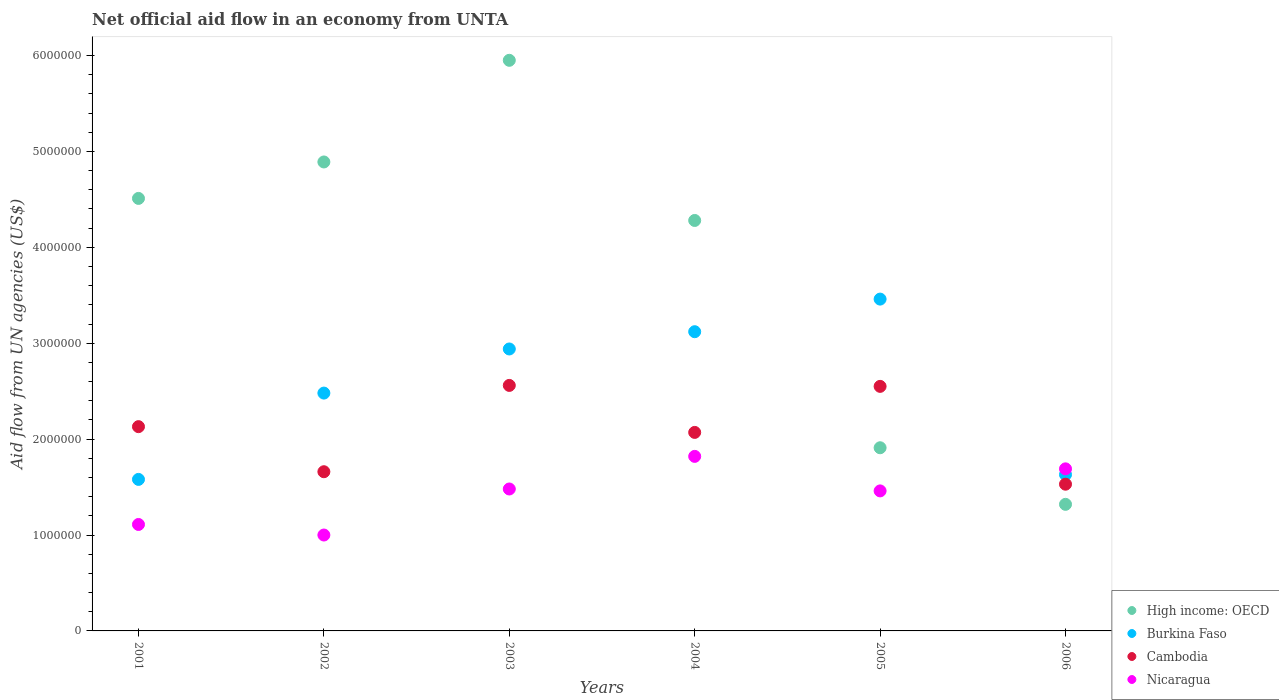Is the number of dotlines equal to the number of legend labels?
Give a very brief answer. Yes. What is the net official aid flow in High income: OECD in 2003?
Your response must be concise. 5.95e+06. Across all years, what is the maximum net official aid flow in Cambodia?
Provide a short and direct response. 2.56e+06. What is the total net official aid flow in Nicaragua in the graph?
Keep it short and to the point. 8.56e+06. What is the difference between the net official aid flow in High income: OECD in 2001 and that in 2006?
Your response must be concise. 3.19e+06. What is the difference between the net official aid flow in Cambodia in 2004 and the net official aid flow in Burkina Faso in 2005?
Your answer should be compact. -1.39e+06. What is the average net official aid flow in Burkina Faso per year?
Keep it short and to the point. 2.54e+06. In the year 2005, what is the difference between the net official aid flow in High income: OECD and net official aid flow in Burkina Faso?
Keep it short and to the point. -1.55e+06. What is the ratio of the net official aid flow in High income: OECD in 2001 to that in 2005?
Your response must be concise. 2.36. Is the difference between the net official aid flow in High income: OECD in 2001 and 2006 greater than the difference between the net official aid flow in Burkina Faso in 2001 and 2006?
Your response must be concise. Yes. What is the difference between the highest and the lowest net official aid flow in Burkina Faso?
Your answer should be compact. 1.88e+06. Is it the case that in every year, the sum of the net official aid flow in Cambodia and net official aid flow in Burkina Faso  is greater than the sum of net official aid flow in Nicaragua and net official aid flow in High income: OECD?
Provide a succinct answer. No. Is it the case that in every year, the sum of the net official aid flow in Burkina Faso and net official aid flow in High income: OECD  is greater than the net official aid flow in Nicaragua?
Give a very brief answer. Yes. Does the net official aid flow in Cambodia monotonically increase over the years?
Your response must be concise. No. Is the net official aid flow in Nicaragua strictly less than the net official aid flow in High income: OECD over the years?
Provide a succinct answer. No. How many dotlines are there?
Offer a very short reply. 4. How many years are there in the graph?
Offer a terse response. 6. Does the graph contain grids?
Your answer should be very brief. No. Where does the legend appear in the graph?
Your response must be concise. Bottom right. How many legend labels are there?
Offer a very short reply. 4. How are the legend labels stacked?
Offer a terse response. Vertical. What is the title of the graph?
Provide a short and direct response. Net official aid flow in an economy from UNTA. Does "Central African Republic" appear as one of the legend labels in the graph?
Offer a very short reply. No. What is the label or title of the Y-axis?
Offer a terse response. Aid flow from UN agencies (US$). What is the Aid flow from UN agencies (US$) in High income: OECD in 2001?
Offer a very short reply. 4.51e+06. What is the Aid flow from UN agencies (US$) in Burkina Faso in 2001?
Your response must be concise. 1.58e+06. What is the Aid flow from UN agencies (US$) of Cambodia in 2001?
Offer a terse response. 2.13e+06. What is the Aid flow from UN agencies (US$) in Nicaragua in 2001?
Provide a succinct answer. 1.11e+06. What is the Aid flow from UN agencies (US$) in High income: OECD in 2002?
Your answer should be compact. 4.89e+06. What is the Aid flow from UN agencies (US$) of Burkina Faso in 2002?
Your answer should be compact. 2.48e+06. What is the Aid flow from UN agencies (US$) in Cambodia in 2002?
Keep it short and to the point. 1.66e+06. What is the Aid flow from UN agencies (US$) of Nicaragua in 2002?
Give a very brief answer. 1.00e+06. What is the Aid flow from UN agencies (US$) of High income: OECD in 2003?
Offer a very short reply. 5.95e+06. What is the Aid flow from UN agencies (US$) of Burkina Faso in 2003?
Make the answer very short. 2.94e+06. What is the Aid flow from UN agencies (US$) in Cambodia in 2003?
Ensure brevity in your answer.  2.56e+06. What is the Aid flow from UN agencies (US$) in Nicaragua in 2003?
Your answer should be very brief. 1.48e+06. What is the Aid flow from UN agencies (US$) in High income: OECD in 2004?
Your answer should be compact. 4.28e+06. What is the Aid flow from UN agencies (US$) of Burkina Faso in 2004?
Offer a terse response. 3.12e+06. What is the Aid flow from UN agencies (US$) in Cambodia in 2004?
Your answer should be compact. 2.07e+06. What is the Aid flow from UN agencies (US$) of Nicaragua in 2004?
Give a very brief answer. 1.82e+06. What is the Aid flow from UN agencies (US$) of High income: OECD in 2005?
Your answer should be compact. 1.91e+06. What is the Aid flow from UN agencies (US$) of Burkina Faso in 2005?
Your answer should be very brief. 3.46e+06. What is the Aid flow from UN agencies (US$) of Cambodia in 2005?
Ensure brevity in your answer.  2.55e+06. What is the Aid flow from UN agencies (US$) in Nicaragua in 2005?
Make the answer very short. 1.46e+06. What is the Aid flow from UN agencies (US$) of High income: OECD in 2006?
Provide a short and direct response. 1.32e+06. What is the Aid flow from UN agencies (US$) in Burkina Faso in 2006?
Offer a very short reply. 1.63e+06. What is the Aid flow from UN agencies (US$) of Cambodia in 2006?
Provide a succinct answer. 1.53e+06. What is the Aid flow from UN agencies (US$) in Nicaragua in 2006?
Provide a succinct answer. 1.69e+06. Across all years, what is the maximum Aid flow from UN agencies (US$) in High income: OECD?
Ensure brevity in your answer.  5.95e+06. Across all years, what is the maximum Aid flow from UN agencies (US$) in Burkina Faso?
Ensure brevity in your answer.  3.46e+06. Across all years, what is the maximum Aid flow from UN agencies (US$) in Cambodia?
Keep it short and to the point. 2.56e+06. Across all years, what is the maximum Aid flow from UN agencies (US$) of Nicaragua?
Provide a short and direct response. 1.82e+06. Across all years, what is the minimum Aid flow from UN agencies (US$) in High income: OECD?
Give a very brief answer. 1.32e+06. Across all years, what is the minimum Aid flow from UN agencies (US$) of Burkina Faso?
Keep it short and to the point. 1.58e+06. Across all years, what is the minimum Aid flow from UN agencies (US$) in Cambodia?
Provide a succinct answer. 1.53e+06. Across all years, what is the minimum Aid flow from UN agencies (US$) in Nicaragua?
Provide a short and direct response. 1.00e+06. What is the total Aid flow from UN agencies (US$) of High income: OECD in the graph?
Offer a very short reply. 2.29e+07. What is the total Aid flow from UN agencies (US$) of Burkina Faso in the graph?
Your answer should be very brief. 1.52e+07. What is the total Aid flow from UN agencies (US$) in Cambodia in the graph?
Ensure brevity in your answer.  1.25e+07. What is the total Aid flow from UN agencies (US$) in Nicaragua in the graph?
Provide a succinct answer. 8.56e+06. What is the difference between the Aid flow from UN agencies (US$) in High income: OECD in 2001 and that in 2002?
Offer a terse response. -3.80e+05. What is the difference between the Aid flow from UN agencies (US$) of Burkina Faso in 2001 and that in 2002?
Ensure brevity in your answer.  -9.00e+05. What is the difference between the Aid flow from UN agencies (US$) in Nicaragua in 2001 and that in 2002?
Provide a short and direct response. 1.10e+05. What is the difference between the Aid flow from UN agencies (US$) in High income: OECD in 2001 and that in 2003?
Keep it short and to the point. -1.44e+06. What is the difference between the Aid flow from UN agencies (US$) in Burkina Faso in 2001 and that in 2003?
Make the answer very short. -1.36e+06. What is the difference between the Aid flow from UN agencies (US$) of Cambodia in 2001 and that in 2003?
Keep it short and to the point. -4.30e+05. What is the difference between the Aid flow from UN agencies (US$) in Nicaragua in 2001 and that in 2003?
Ensure brevity in your answer.  -3.70e+05. What is the difference between the Aid flow from UN agencies (US$) of High income: OECD in 2001 and that in 2004?
Offer a very short reply. 2.30e+05. What is the difference between the Aid flow from UN agencies (US$) of Burkina Faso in 2001 and that in 2004?
Make the answer very short. -1.54e+06. What is the difference between the Aid flow from UN agencies (US$) of Cambodia in 2001 and that in 2004?
Offer a very short reply. 6.00e+04. What is the difference between the Aid flow from UN agencies (US$) of Nicaragua in 2001 and that in 2004?
Ensure brevity in your answer.  -7.10e+05. What is the difference between the Aid flow from UN agencies (US$) of High income: OECD in 2001 and that in 2005?
Keep it short and to the point. 2.60e+06. What is the difference between the Aid flow from UN agencies (US$) of Burkina Faso in 2001 and that in 2005?
Your answer should be very brief. -1.88e+06. What is the difference between the Aid flow from UN agencies (US$) of Cambodia in 2001 and that in 2005?
Your answer should be compact. -4.20e+05. What is the difference between the Aid flow from UN agencies (US$) in Nicaragua in 2001 and that in 2005?
Give a very brief answer. -3.50e+05. What is the difference between the Aid flow from UN agencies (US$) in High income: OECD in 2001 and that in 2006?
Provide a short and direct response. 3.19e+06. What is the difference between the Aid flow from UN agencies (US$) of Cambodia in 2001 and that in 2006?
Ensure brevity in your answer.  6.00e+05. What is the difference between the Aid flow from UN agencies (US$) in Nicaragua in 2001 and that in 2006?
Make the answer very short. -5.80e+05. What is the difference between the Aid flow from UN agencies (US$) in High income: OECD in 2002 and that in 2003?
Ensure brevity in your answer.  -1.06e+06. What is the difference between the Aid flow from UN agencies (US$) in Burkina Faso in 2002 and that in 2003?
Your response must be concise. -4.60e+05. What is the difference between the Aid flow from UN agencies (US$) of Cambodia in 2002 and that in 2003?
Give a very brief answer. -9.00e+05. What is the difference between the Aid flow from UN agencies (US$) in Nicaragua in 2002 and that in 2003?
Your response must be concise. -4.80e+05. What is the difference between the Aid flow from UN agencies (US$) of Burkina Faso in 2002 and that in 2004?
Your answer should be very brief. -6.40e+05. What is the difference between the Aid flow from UN agencies (US$) in Cambodia in 2002 and that in 2004?
Provide a short and direct response. -4.10e+05. What is the difference between the Aid flow from UN agencies (US$) of Nicaragua in 2002 and that in 2004?
Offer a terse response. -8.20e+05. What is the difference between the Aid flow from UN agencies (US$) of High income: OECD in 2002 and that in 2005?
Your response must be concise. 2.98e+06. What is the difference between the Aid flow from UN agencies (US$) of Burkina Faso in 2002 and that in 2005?
Offer a very short reply. -9.80e+05. What is the difference between the Aid flow from UN agencies (US$) in Cambodia in 2002 and that in 2005?
Your answer should be very brief. -8.90e+05. What is the difference between the Aid flow from UN agencies (US$) of Nicaragua in 2002 and that in 2005?
Offer a terse response. -4.60e+05. What is the difference between the Aid flow from UN agencies (US$) in High income: OECD in 2002 and that in 2006?
Offer a very short reply. 3.57e+06. What is the difference between the Aid flow from UN agencies (US$) of Burkina Faso in 2002 and that in 2006?
Offer a terse response. 8.50e+05. What is the difference between the Aid flow from UN agencies (US$) in Cambodia in 2002 and that in 2006?
Your answer should be compact. 1.30e+05. What is the difference between the Aid flow from UN agencies (US$) in Nicaragua in 2002 and that in 2006?
Your answer should be compact. -6.90e+05. What is the difference between the Aid flow from UN agencies (US$) of High income: OECD in 2003 and that in 2004?
Make the answer very short. 1.67e+06. What is the difference between the Aid flow from UN agencies (US$) in Burkina Faso in 2003 and that in 2004?
Your answer should be very brief. -1.80e+05. What is the difference between the Aid flow from UN agencies (US$) of High income: OECD in 2003 and that in 2005?
Keep it short and to the point. 4.04e+06. What is the difference between the Aid flow from UN agencies (US$) of Burkina Faso in 2003 and that in 2005?
Provide a short and direct response. -5.20e+05. What is the difference between the Aid flow from UN agencies (US$) of Nicaragua in 2003 and that in 2005?
Offer a very short reply. 2.00e+04. What is the difference between the Aid flow from UN agencies (US$) of High income: OECD in 2003 and that in 2006?
Provide a short and direct response. 4.63e+06. What is the difference between the Aid flow from UN agencies (US$) of Burkina Faso in 2003 and that in 2006?
Keep it short and to the point. 1.31e+06. What is the difference between the Aid flow from UN agencies (US$) of Cambodia in 2003 and that in 2006?
Your response must be concise. 1.03e+06. What is the difference between the Aid flow from UN agencies (US$) of Nicaragua in 2003 and that in 2006?
Make the answer very short. -2.10e+05. What is the difference between the Aid flow from UN agencies (US$) in High income: OECD in 2004 and that in 2005?
Ensure brevity in your answer.  2.37e+06. What is the difference between the Aid flow from UN agencies (US$) of Cambodia in 2004 and that in 2005?
Offer a terse response. -4.80e+05. What is the difference between the Aid flow from UN agencies (US$) of Nicaragua in 2004 and that in 2005?
Provide a short and direct response. 3.60e+05. What is the difference between the Aid flow from UN agencies (US$) in High income: OECD in 2004 and that in 2006?
Your response must be concise. 2.96e+06. What is the difference between the Aid flow from UN agencies (US$) in Burkina Faso in 2004 and that in 2006?
Your answer should be compact. 1.49e+06. What is the difference between the Aid flow from UN agencies (US$) of Cambodia in 2004 and that in 2006?
Provide a short and direct response. 5.40e+05. What is the difference between the Aid flow from UN agencies (US$) in High income: OECD in 2005 and that in 2006?
Make the answer very short. 5.90e+05. What is the difference between the Aid flow from UN agencies (US$) of Burkina Faso in 2005 and that in 2006?
Your answer should be compact. 1.83e+06. What is the difference between the Aid flow from UN agencies (US$) in Cambodia in 2005 and that in 2006?
Your answer should be very brief. 1.02e+06. What is the difference between the Aid flow from UN agencies (US$) of Nicaragua in 2005 and that in 2006?
Offer a very short reply. -2.30e+05. What is the difference between the Aid flow from UN agencies (US$) of High income: OECD in 2001 and the Aid flow from UN agencies (US$) of Burkina Faso in 2002?
Keep it short and to the point. 2.03e+06. What is the difference between the Aid flow from UN agencies (US$) in High income: OECD in 2001 and the Aid flow from UN agencies (US$) in Cambodia in 2002?
Provide a succinct answer. 2.85e+06. What is the difference between the Aid flow from UN agencies (US$) in High income: OECD in 2001 and the Aid flow from UN agencies (US$) in Nicaragua in 2002?
Make the answer very short. 3.51e+06. What is the difference between the Aid flow from UN agencies (US$) of Burkina Faso in 2001 and the Aid flow from UN agencies (US$) of Nicaragua in 2002?
Make the answer very short. 5.80e+05. What is the difference between the Aid flow from UN agencies (US$) of Cambodia in 2001 and the Aid flow from UN agencies (US$) of Nicaragua in 2002?
Ensure brevity in your answer.  1.13e+06. What is the difference between the Aid flow from UN agencies (US$) of High income: OECD in 2001 and the Aid flow from UN agencies (US$) of Burkina Faso in 2003?
Provide a short and direct response. 1.57e+06. What is the difference between the Aid flow from UN agencies (US$) in High income: OECD in 2001 and the Aid flow from UN agencies (US$) in Cambodia in 2003?
Make the answer very short. 1.95e+06. What is the difference between the Aid flow from UN agencies (US$) of High income: OECD in 2001 and the Aid flow from UN agencies (US$) of Nicaragua in 2003?
Your answer should be very brief. 3.03e+06. What is the difference between the Aid flow from UN agencies (US$) in Burkina Faso in 2001 and the Aid flow from UN agencies (US$) in Cambodia in 2003?
Give a very brief answer. -9.80e+05. What is the difference between the Aid flow from UN agencies (US$) in Burkina Faso in 2001 and the Aid flow from UN agencies (US$) in Nicaragua in 2003?
Your answer should be very brief. 1.00e+05. What is the difference between the Aid flow from UN agencies (US$) of Cambodia in 2001 and the Aid flow from UN agencies (US$) of Nicaragua in 2003?
Your response must be concise. 6.50e+05. What is the difference between the Aid flow from UN agencies (US$) of High income: OECD in 2001 and the Aid flow from UN agencies (US$) of Burkina Faso in 2004?
Make the answer very short. 1.39e+06. What is the difference between the Aid flow from UN agencies (US$) of High income: OECD in 2001 and the Aid flow from UN agencies (US$) of Cambodia in 2004?
Offer a terse response. 2.44e+06. What is the difference between the Aid flow from UN agencies (US$) of High income: OECD in 2001 and the Aid flow from UN agencies (US$) of Nicaragua in 2004?
Your answer should be very brief. 2.69e+06. What is the difference between the Aid flow from UN agencies (US$) in Burkina Faso in 2001 and the Aid flow from UN agencies (US$) in Cambodia in 2004?
Give a very brief answer. -4.90e+05. What is the difference between the Aid flow from UN agencies (US$) in Burkina Faso in 2001 and the Aid flow from UN agencies (US$) in Nicaragua in 2004?
Your answer should be compact. -2.40e+05. What is the difference between the Aid flow from UN agencies (US$) in High income: OECD in 2001 and the Aid flow from UN agencies (US$) in Burkina Faso in 2005?
Provide a short and direct response. 1.05e+06. What is the difference between the Aid flow from UN agencies (US$) in High income: OECD in 2001 and the Aid flow from UN agencies (US$) in Cambodia in 2005?
Your answer should be compact. 1.96e+06. What is the difference between the Aid flow from UN agencies (US$) in High income: OECD in 2001 and the Aid flow from UN agencies (US$) in Nicaragua in 2005?
Keep it short and to the point. 3.05e+06. What is the difference between the Aid flow from UN agencies (US$) of Burkina Faso in 2001 and the Aid flow from UN agencies (US$) of Cambodia in 2005?
Make the answer very short. -9.70e+05. What is the difference between the Aid flow from UN agencies (US$) in Cambodia in 2001 and the Aid flow from UN agencies (US$) in Nicaragua in 2005?
Make the answer very short. 6.70e+05. What is the difference between the Aid flow from UN agencies (US$) in High income: OECD in 2001 and the Aid flow from UN agencies (US$) in Burkina Faso in 2006?
Provide a succinct answer. 2.88e+06. What is the difference between the Aid flow from UN agencies (US$) in High income: OECD in 2001 and the Aid flow from UN agencies (US$) in Cambodia in 2006?
Offer a very short reply. 2.98e+06. What is the difference between the Aid flow from UN agencies (US$) in High income: OECD in 2001 and the Aid flow from UN agencies (US$) in Nicaragua in 2006?
Offer a terse response. 2.82e+06. What is the difference between the Aid flow from UN agencies (US$) of High income: OECD in 2002 and the Aid flow from UN agencies (US$) of Burkina Faso in 2003?
Your answer should be compact. 1.95e+06. What is the difference between the Aid flow from UN agencies (US$) in High income: OECD in 2002 and the Aid flow from UN agencies (US$) in Cambodia in 2003?
Offer a very short reply. 2.33e+06. What is the difference between the Aid flow from UN agencies (US$) in High income: OECD in 2002 and the Aid flow from UN agencies (US$) in Nicaragua in 2003?
Provide a short and direct response. 3.41e+06. What is the difference between the Aid flow from UN agencies (US$) in Burkina Faso in 2002 and the Aid flow from UN agencies (US$) in Cambodia in 2003?
Provide a succinct answer. -8.00e+04. What is the difference between the Aid flow from UN agencies (US$) of High income: OECD in 2002 and the Aid flow from UN agencies (US$) of Burkina Faso in 2004?
Ensure brevity in your answer.  1.77e+06. What is the difference between the Aid flow from UN agencies (US$) of High income: OECD in 2002 and the Aid flow from UN agencies (US$) of Cambodia in 2004?
Your answer should be compact. 2.82e+06. What is the difference between the Aid flow from UN agencies (US$) of High income: OECD in 2002 and the Aid flow from UN agencies (US$) of Nicaragua in 2004?
Your answer should be compact. 3.07e+06. What is the difference between the Aid flow from UN agencies (US$) of Burkina Faso in 2002 and the Aid flow from UN agencies (US$) of Nicaragua in 2004?
Provide a short and direct response. 6.60e+05. What is the difference between the Aid flow from UN agencies (US$) in Cambodia in 2002 and the Aid flow from UN agencies (US$) in Nicaragua in 2004?
Give a very brief answer. -1.60e+05. What is the difference between the Aid flow from UN agencies (US$) in High income: OECD in 2002 and the Aid flow from UN agencies (US$) in Burkina Faso in 2005?
Provide a succinct answer. 1.43e+06. What is the difference between the Aid flow from UN agencies (US$) in High income: OECD in 2002 and the Aid flow from UN agencies (US$) in Cambodia in 2005?
Give a very brief answer. 2.34e+06. What is the difference between the Aid flow from UN agencies (US$) in High income: OECD in 2002 and the Aid flow from UN agencies (US$) in Nicaragua in 2005?
Ensure brevity in your answer.  3.43e+06. What is the difference between the Aid flow from UN agencies (US$) of Burkina Faso in 2002 and the Aid flow from UN agencies (US$) of Cambodia in 2005?
Your answer should be compact. -7.00e+04. What is the difference between the Aid flow from UN agencies (US$) of Burkina Faso in 2002 and the Aid flow from UN agencies (US$) of Nicaragua in 2005?
Provide a succinct answer. 1.02e+06. What is the difference between the Aid flow from UN agencies (US$) of High income: OECD in 2002 and the Aid flow from UN agencies (US$) of Burkina Faso in 2006?
Provide a short and direct response. 3.26e+06. What is the difference between the Aid flow from UN agencies (US$) in High income: OECD in 2002 and the Aid flow from UN agencies (US$) in Cambodia in 2006?
Your answer should be very brief. 3.36e+06. What is the difference between the Aid flow from UN agencies (US$) in High income: OECD in 2002 and the Aid flow from UN agencies (US$) in Nicaragua in 2006?
Keep it short and to the point. 3.20e+06. What is the difference between the Aid flow from UN agencies (US$) in Burkina Faso in 2002 and the Aid flow from UN agencies (US$) in Cambodia in 2006?
Provide a succinct answer. 9.50e+05. What is the difference between the Aid flow from UN agencies (US$) of Burkina Faso in 2002 and the Aid flow from UN agencies (US$) of Nicaragua in 2006?
Keep it short and to the point. 7.90e+05. What is the difference between the Aid flow from UN agencies (US$) in High income: OECD in 2003 and the Aid flow from UN agencies (US$) in Burkina Faso in 2004?
Make the answer very short. 2.83e+06. What is the difference between the Aid flow from UN agencies (US$) of High income: OECD in 2003 and the Aid flow from UN agencies (US$) of Cambodia in 2004?
Your response must be concise. 3.88e+06. What is the difference between the Aid flow from UN agencies (US$) of High income: OECD in 2003 and the Aid flow from UN agencies (US$) of Nicaragua in 2004?
Offer a very short reply. 4.13e+06. What is the difference between the Aid flow from UN agencies (US$) in Burkina Faso in 2003 and the Aid flow from UN agencies (US$) in Cambodia in 2004?
Your answer should be very brief. 8.70e+05. What is the difference between the Aid flow from UN agencies (US$) of Burkina Faso in 2003 and the Aid flow from UN agencies (US$) of Nicaragua in 2004?
Your answer should be very brief. 1.12e+06. What is the difference between the Aid flow from UN agencies (US$) of Cambodia in 2003 and the Aid flow from UN agencies (US$) of Nicaragua in 2004?
Provide a succinct answer. 7.40e+05. What is the difference between the Aid flow from UN agencies (US$) of High income: OECD in 2003 and the Aid flow from UN agencies (US$) of Burkina Faso in 2005?
Your answer should be compact. 2.49e+06. What is the difference between the Aid flow from UN agencies (US$) in High income: OECD in 2003 and the Aid flow from UN agencies (US$) in Cambodia in 2005?
Keep it short and to the point. 3.40e+06. What is the difference between the Aid flow from UN agencies (US$) in High income: OECD in 2003 and the Aid flow from UN agencies (US$) in Nicaragua in 2005?
Keep it short and to the point. 4.49e+06. What is the difference between the Aid flow from UN agencies (US$) of Burkina Faso in 2003 and the Aid flow from UN agencies (US$) of Nicaragua in 2005?
Provide a short and direct response. 1.48e+06. What is the difference between the Aid flow from UN agencies (US$) of Cambodia in 2003 and the Aid flow from UN agencies (US$) of Nicaragua in 2005?
Make the answer very short. 1.10e+06. What is the difference between the Aid flow from UN agencies (US$) of High income: OECD in 2003 and the Aid flow from UN agencies (US$) of Burkina Faso in 2006?
Keep it short and to the point. 4.32e+06. What is the difference between the Aid flow from UN agencies (US$) in High income: OECD in 2003 and the Aid flow from UN agencies (US$) in Cambodia in 2006?
Keep it short and to the point. 4.42e+06. What is the difference between the Aid flow from UN agencies (US$) of High income: OECD in 2003 and the Aid flow from UN agencies (US$) of Nicaragua in 2006?
Your answer should be very brief. 4.26e+06. What is the difference between the Aid flow from UN agencies (US$) of Burkina Faso in 2003 and the Aid flow from UN agencies (US$) of Cambodia in 2006?
Your answer should be compact. 1.41e+06. What is the difference between the Aid flow from UN agencies (US$) of Burkina Faso in 2003 and the Aid flow from UN agencies (US$) of Nicaragua in 2006?
Provide a succinct answer. 1.25e+06. What is the difference between the Aid flow from UN agencies (US$) of Cambodia in 2003 and the Aid flow from UN agencies (US$) of Nicaragua in 2006?
Provide a short and direct response. 8.70e+05. What is the difference between the Aid flow from UN agencies (US$) of High income: OECD in 2004 and the Aid flow from UN agencies (US$) of Burkina Faso in 2005?
Provide a short and direct response. 8.20e+05. What is the difference between the Aid flow from UN agencies (US$) in High income: OECD in 2004 and the Aid flow from UN agencies (US$) in Cambodia in 2005?
Your response must be concise. 1.73e+06. What is the difference between the Aid flow from UN agencies (US$) in High income: OECD in 2004 and the Aid flow from UN agencies (US$) in Nicaragua in 2005?
Your response must be concise. 2.82e+06. What is the difference between the Aid flow from UN agencies (US$) in Burkina Faso in 2004 and the Aid flow from UN agencies (US$) in Cambodia in 2005?
Provide a succinct answer. 5.70e+05. What is the difference between the Aid flow from UN agencies (US$) of Burkina Faso in 2004 and the Aid flow from UN agencies (US$) of Nicaragua in 2005?
Offer a very short reply. 1.66e+06. What is the difference between the Aid flow from UN agencies (US$) in High income: OECD in 2004 and the Aid flow from UN agencies (US$) in Burkina Faso in 2006?
Make the answer very short. 2.65e+06. What is the difference between the Aid flow from UN agencies (US$) in High income: OECD in 2004 and the Aid flow from UN agencies (US$) in Cambodia in 2006?
Provide a succinct answer. 2.75e+06. What is the difference between the Aid flow from UN agencies (US$) in High income: OECD in 2004 and the Aid flow from UN agencies (US$) in Nicaragua in 2006?
Give a very brief answer. 2.59e+06. What is the difference between the Aid flow from UN agencies (US$) in Burkina Faso in 2004 and the Aid flow from UN agencies (US$) in Cambodia in 2006?
Keep it short and to the point. 1.59e+06. What is the difference between the Aid flow from UN agencies (US$) in Burkina Faso in 2004 and the Aid flow from UN agencies (US$) in Nicaragua in 2006?
Give a very brief answer. 1.43e+06. What is the difference between the Aid flow from UN agencies (US$) in High income: OECD in 2005 and the Aid flow from UN agencies (US$) in Cambodia in 2006?
Provide a succinct answer. 3.80e+05. What is the difference between the Aid flow from UN agencies (US$) in High income: OECD in 2005 and the Aid flow from UN agencies (US$) in Nicaragua in 2006?
Your answer should be very brief. 2.20e+05. What is the difference between the Aid flow from UN agencies (US$) in Burkina Faso in 2005 and the Aid flow from UN agencies (US$) in Cambodia in 2006?
Make the answer very short. 1.93e+06. What is the difference between the Aid flow from UN agencies (US$) in Burkina Faso in 2005 and the Aid flow from UN agencies (US$) in Nicaragua in 2006?
Your response must be concise. 1.77e+06. What is the difference between the Aid flow from UN agencies (US$) of Cambodia in 2005 and the Aid flow from UN agencies (US$) of Nicaragua in 2006?
Your response must be concise. 8.60e+05. What is the average Aid flow from UN agencies (US$) of High income: OECD per year?
Provide a succinct answer. 3.81e+06. What is the average Aid flow from UN agencies (US$) in Burkina Faso per year?
Give a very brief answer. 2.54e+06. What is the average Aid flow from UN agencies (US$) in Cambodia per year?
Your response must be concise. 2.08e+06. What is the average Aid flow from UN agencies (US$) in Nicaragua per year?
Make the answer very short. 1.43e+06. In the year 2001, what is the difference between the Aid flow from UN agencies (US$) in High income: OECD and Aid flow from UN agencies (US$) in Burkina Faso?
Your answer should be compact. 2.93e+06. In the year 2001, what is the difference between the Aid flow from UN agencies (US$) of High income: OECD and Aid flow from UN agencies (US$) of Cambodia?
Give a very brief answer. 2.38e+06. In the year 2001, what is the difference between the Aid flow from UN agencies (US$) of High income: OECD and Aid flow from UN agencies (US$) of Nicaragua?
Keep it short and to the point. 3.40e+06. In the year 2001, what is the difference between the Aid flow from UN agencies (US$) of Burkina Faso and Aid flow from UN agencies (US$) of Cambodia?
Your answer should be very brief. -5.50e+05. In the year 2001, what is the difference between the Aid flow from UN agencies (US$) in Cambodia and Aid flow from UN agencies (US$) in Nicaragua?
Give a very brief answer. 1.02e+06. In the year 2002, what is the difference between the Aid flow from UN agencies (US$) of High income: OECD and Aid flow from UN agencies (US$) of Burkina Faso?
Provide a short and direct response. 2.41e+06. In the year 2002, what is the difference between the Aid flow from UN agencies (US$) in High income: OECD and Aid flow from UN agencies (US$) in Cambodia?
Your answer should be very brief. 3.23e+06. In the year 2002, what is the difference between the Aid flow from UN agencies (US$) of High income: OECD and Aid flow from UN agencies (US$) of Nicaragua?
Provide a short and direct response. 3.89e+06. In the year 2002, what is the difference between the Aid flow from UN agencies (US$) of Burkina Faso and Aid flow from UN agencies (US$) of Cambodia?
Offer a terse response. 8.20e+05. In the year 2002, what is the difference between the Aid flow from UN agencies (US$) of Burkina Faso and Aid flow from UN agencies (US$) of Nicaragua?
Your response must be concise. 1.48e+06. In the year 2002, what is the difference between the Aid flow from UN agencies (US$) of Cambodia and Aid flow from UN agencies (US$) of Nicaragua?
Provide a short and direct response. 6.60e+05. In the year 2003, what is the difference between the Aid flow from UN agencies (US$) of High income: OECD and Aid flow from UN agencies (US$) of Burkina Faso?
Provide a short and direct response. 3.01e+06. In the year 2003, what is the difference between the Aid flow from UN agencies (US$) of High income: OECD and Aid flow from UN agencies (US$) of Cambodia?
Your answer should be very brief. 3.39e+06. In the year 2003, what is the difference between the Aid flow from UN agencies (US$) of High income: OECD and Aid flow from UN agencies (US$) of Nicaragua?
Your response must be concise. 4.47e+06. In the year 2003, what is the difference between the Aid flow from UN agencies (US$) in Burkina Faso and Aid flow from UN agencies (US$) in Nicaragua?
Ensure brevity in your answer.  1.46e+06. In the year 2003, what is the difference between the Aid flow from UN agencies (US$) in Cambodia and Aid flow from UN agencies (US$) in Nicaragua?
Make the answer very short. 1.08e+06. In the year 2004, what is the difference between the Aid flow from UN agencies (US$) of High income: OECD and Aid flow from UN agencies (US$) of Burkina Faso?
Offer a very short reply. 1.16e+06. In the year 2004, what is the difference between the Aid flow from UN agencies (US$) in High income: OECD and Aid flow from UN agencies (US$) in Cambodia?
Offer a terse response. 2.21e+06. In the year 2004, what is the difference between the Aid flow from UN agencies (US$) in High income: OECD and Aid flow from UN agencies (US$) in Nicaragua?
Your answer should be very brief. 2.46e+06. In the year 2004, what is the difference between the Aid flow from UN agencies (US$) in Burkina Faso and Aid flow from UN agencies (US$) in Cambodia?
Make the answer very short. 1.05e+06. In the year 2004, what is the difference between the Aid flow from UN agencies (US$) of Burkina Faso and Aid flow from UN agencies (US$) of Nicaragua?
Offer a very short reply. 1.30e+06. In the year 2005, what is the difference between the Aid flow from UN agencies (US$) in High income: OECD and Aid flow from UN agencies (US$) in Burkina Faso?
Give a very brief answer. -1.55e+06. In the year 2005, what is the difference between the Aid flow from UN agencies (US$) in High income: OECD and Aid flow from UN agencies (US$) in Cambodia?
Offer a terse response. -6.40e+05. In the year 2005, what is the difference between the Aid flow from UN agencies (US$) in High income: OECD and Aid flow from UN agencies (US$) in Nicaragua?
Keep it short and to the point. 4.50e+05. In the year 2005, what is the difference between the Aid flow from UN agencies (US$) of Burkina Faso and Aid flow from UN agencies (US$) of Cambodia?
Your response must be concise. 9.10e+05. In the year 2005, what is the difference between the Aid flow from UN agencies (US$) of Burkina Faso and Aid flow from UN agencies (US$) of Nicaragua?
Provide a short and direct response. 2.00e+06. In the year 2005, what is the difference between the Aid flow from UN agencies (US$) of Cambodia and Aid flow from UN agencies (US$) of Nicaragua?
Give a very brief answer. 1.09e+06. In the year 2006, what is the difference between the Aid flow from UN agencies (US$) in High income: OECD and Aid flow from UN agencies (US$) in Burkina Faso?
Keep it short and to the point. -3.10e+05. In the year 2006, what is the difference between the Aid flow from UN agencies (US$) of High income: OECD and Aid flow from UN agencies (US$) of Cambodia?
Keep it short and to the point. -2.10e+05. In the year 2006, what is the difference between the Aid flow from UN agencies (US$) in High income: OECD and Aid flow from UN agencies (US$) in Nicaragua?
Your answer should be very brief. -3.70e+05. In the year 2006, what is the difference between the Aid flow from UN agencies (US$) in Burkina Faso and Aid flow from UN agencies (US$) in Cambodia?
Provide a short and direct response. 1.00e+05. In the year 2006, what is the difference between the Aid flow from UN agencies (US$) of Burkina Faso and Aid flow from UN agencies (US$) of Nicaragua?
Your answer should be compact. -6.00e+04. What is the ratio of the Aid flow from UN agencies (US$) of High income: OECD in 2001 to that in 2002?
Offer a very short reply. 0.92. What is the ratio of the Aid flow from UN agencies (US$) in Burkina Faso in 2001 to that in 2002?
Your answer should be compact. 0.64. What is the ratio of the Aid flow from UN agencies (US$) of Cambodia in 2001 to that in 2002?
Your answer should be compact. 1.28. What is the ratio of the Aid flow from UN agencies (US$) of Nicaragua in 2001 to that in 2002?
Make the answer very short. 1.11. What is the ratio of the Aid flow from UN agencies (US$) of High income: OECD in 2001 to that in 2003?
Your answer should be very brief. 0.76. What is the ratio of the Aid flow from UN agencies (US$) of Burkina Faso in 2001 to that in 2003?
Provide a short and direct response. 0.54. What is the ratio of the Aid flow from UN agencies (US$) of Cambodia in 2001 to that in 2003?
Your response must be concise. 0.83. What is the ratio of the Aid flow from UN agencies (US$) in High income: OECD in 2001 to that in 2004?
Ensure brevity in your answer.  1.05. What is the ratio of the Aid flow from UN agencies (US$) in Burkina Faso in 2001 to that in 2004?
Offer a terse response. 0.51. What is the ratio of the Aid flow from UN agencies (US$) of Nicaragua in 2001 to that in 2004?
Offer a terse response. 0.61. What is the ratio of the Aid flow from UN agencies (US$) of High income: OECD in 2001 to that in 2005?
Offer a terse response. 2.36. What is the ratio of the Aid flow from UN agencies (US$) in Burkina Faso in 2001 to that in 2005?
Offer a very short reply. 0.46. What is the ratio of the Aid flow from UN agencies (US$) in Cambodia in 2001 to that in 2005?
Ensure brevity in your answer.  0.84. What is the ratio of the Aid flow from UN agencies (US$) in Nicaragua in 2001 to that in 2005?
Your response must be concise. 0.76. What is the ratio of the Aid flow from UN agencies (US$) of High income: OECD in 2001 to that in 2006?
Offer a terse response. 3.42. What is the ratio of the Aid flow from UN agencies (US$) of Burkina Faso in 2001 to that in 2006?
Give a very brief answer. 0.97. What is the ratio of the Aid flow from UN agencies (US$) of Cambodia in 2001 to that in 2006?
Give a very brief answer. 1.39. What is the ratio of the Aid flow from UN agencies (US$) of Nicaragua in 2001 to that in 2006?
Your response must be concise. 0.66. What is the ratio of the Aid flow from UN agencies (US$) of High income: OECD in 2002 to that in 2003?
Ensure brevity in your answer.  0.82. What is the ratio of the Aid flow from UN agencies (US$) of Burkina Faso in 2002 to that in 2003?
Provide a short and direct response. 0.84. What is the ratio of the Aid flow from UN agencies (US$) of Cambodia in 2002 to that in 2003?
Offer a terse response. 0.65. What is the ratio of the Aid flow from UN agencies (US$) in Nicaragua in 2002 to that in 2003?
Offer a very short reply. 0.68. What is the ratio of the Aid flow from UN agencies (US$) of High income: OECD in 2002 to that in 2004?
Offer a very short reply. 1.14. What is the ratio of the Aid flow from UN agencies (US$) of Burkina Faso in 2002 to that in 2004?
Give a very brief answer. 0.79. What is the ratio of the Aid flow from UN agencies (US$) of Cambodia in 2002 to that in 2004?
Provide a short and direct response. 0.8. What is the ratio of the Aid flow from UN agencies (US$) in Nicaragua in 2002 to that in 2004?
Your answer should be very brief. 0.55. What is the ratio of the Aid flow from UN agencies (US$) in High income: OECD in 2002 to that in 2005?
Provide a succinct answer. 2.56. What is the ratio of the Aid flow from UN agencies (US$) in Burkina Faso in 2002 to that in 2005?
Provide a short and direct response. 0.72. What is the ratio of the Aid flow from UN agencies (US$) in Cambodia in 2002 to that in 2005?
Your answer should be very brief. 0.65. What is the ratio of the Aid flow from UN agencies (US$) in Nicaragua in 2002 to that in 2005?
Offer a very short reply. 0.68. What is the ratio of the Aid flow from UN agencies (US$) of High income: OECD in 2002 to that in 2006?
Your answer should be very brief. 3.7. What is the ratio of the Aid flow from UN agencies (US$) of Burkina Faso in 2002 to that in 2006?
Your response must be concise. 1.52. What is the ratio of the Aid flow from UN agencies (US$) in Cambodia in 2002 to that in 2006?
Give a very brief answer. 1.08. What is the ratio of the Aid flow from UN agencies (US$) of Nicaragua in 2002 to that in 2006?
Offer a terse response. 0.59. What is the ratio of the Aid flow from UN agencies (US$) of High income: OECD in 2003 to that in 2004?
Provide a succinct answer. 1.39. What is the ratio of the Aid flow from UN agencies (US$) of Burkina Faso in 2003 to that in 2004?
Ensure brevity in your answer.  0.94. What is the ratio of the Aid flow from UN agencies (US$) of Cambodia in 2003 to that in 2004?
Ensure brevity in your answer.  1.24. What is the ratio of the Aid flow from UN agencies (US$) in Nicaragua in 2003 to that in 2004?
Offer a terse response. 0.81. What is the ratio of the Aid flow from UN agencies (US$) in High income: OECD in 2003 to that in 2005?
Make the answer very short. 3.12. What is the ratio of the Aid flow from UN agencies (US$) in Burkina Faso in 2003 to that in 2005?
Offer a very short reply. 0.85. What is the ratio of the Aid flow from UN agencies (US$) of Cambodia in 2003 to that in 2005?
Ensure brevity in your answer.  1. What is the ratio of the Aid flow from UN agencies (US$) in Nicaragua in 2003 to that in 2005?
Offer a very short reply. 1.01. What is the ratio of the Aid flow from UN agencies (US$) of High income: OECD in 2003 to that in 2006?
Give a very brief answer. 4.51. What is the ratio of the Aid flow from UN agencies (US$) in Burkina Faso in 2003 to that in 2006?
Your answer should be compact. 1.8. What is the ratio of the Aid flow from UN agencies (US$) in Cambodia in 2003 to that in 2006?
Provide a short and direct response. 1.67. What is the ratio of the Aid flow from UN agencies (US$) of Nicaragua in 2003 to that in 2006?
Provide a short and direct response. 0.88. What is the ratio of the Aid flow from UN agencies (US$) of High income: OECD in 2004 to that in 2005?
Offer a very short reply. 2.24. What is the ratio of the Aid flow from UN agencies (US$) in Burkina Faso in 2004 to that in 2005?
Keep it short and to the point. 0.9. What is the ratio of the Aid flow from UN agencies (US$) of Cambodia in 2004 to that in 2005?
Ensure brevity in your answer.  0.81. What is the ratio of the Aid flow from UN agencies (US$) of Nicaragua in 2004 to that in 2005?
Give a very brief answer. 1.25. What is the ratio of the Aid flow from UN agencies (US$) of High income: OECD in 2004 to that in 2006?
Give a very brief answer. 3.24. What is the ratio of the Aid flow from UN agencies (US$) in Burkina Faso in 2004 to that in 2006?
Your answer should be compact. 1.91. What is the ratio of the Aid flow from UN agencies (US$) of Cambodia in 2004 to that in 2006?
Provide a succinct answer. 1.35. What is the ratio of the Aid flow from UN agencies (US$) of High income: OECD in 2005 to that in 2006?
Keep it short and to the point. 1.45. What is the ratio of the Aid flow from UN agencies (US$) in Burkina Faso in 2005 to that in 2006?
Ensure brevity in your answer.  2.12. What is the ratio of the Aid flow from UN agencies (US$) of Cambodia in 2005 to that in 2006?
Give a very brief answer. 1.67. What is the ratio of the Aid flow from UN agencies (US$) in Nicaragua in 2005 to that in 2006?
Your answer should be very brief. 0.86. What is the difference between the highest and the second highest Aid flow from UN agencies (US$) in High income: OECD?
Give a very brief answer. 1.06e+06. What is the difference between the highest and the second highest Aid flow from UN agencies (US$) of Nicaragua?
Give a very brief answer. 1.30e+05. What is the difference between the highest and the lowest Aid flow from UN agencies (US$) in High income: OECD?
Your answer should be very brief. 4.63e+06. What is the difference between the highest and the lowest Aid flow from UN agencies (US$) of Burkina Faso?
Your response must be concise. 1.88e+06. What is the difference between the highest and the lowest Aid flow from UN agencies (US$) of Cambodia?
Provide a succinct answer. 1.03e+06. What is the difference between the highest and the lowest Aid flow from UN agencies (US$) in Nicaragua?
Keep it short and to the point. 8.20e+05. 